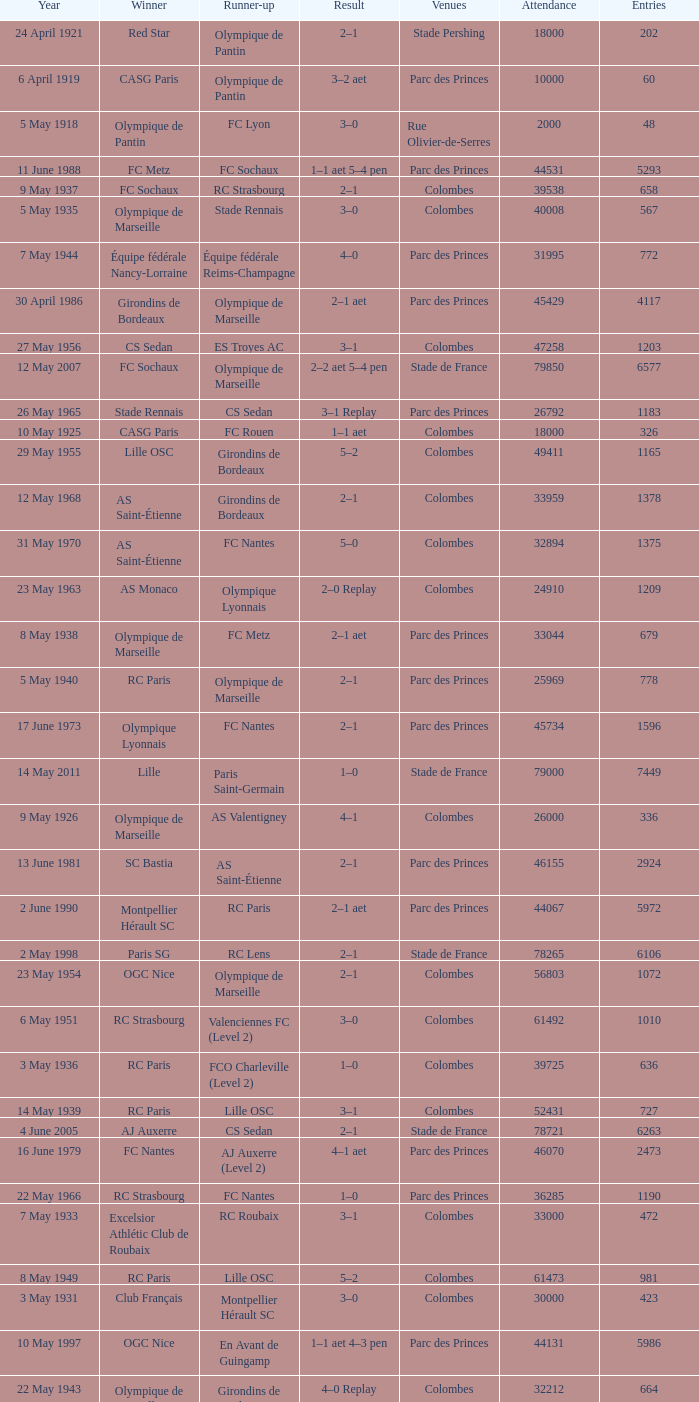What is the fewest recorded entrants against paris saint-germain? 6394.0. 